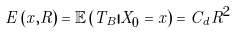<formula> <loc_0><loc_0><loc_500><loc_500>E \left ( x , R \right ) = \mathbb { E } \left ( T _ { B } | X _ { 0 } = x \right ) = C _ { d } R ^ { 2 }</formula> 